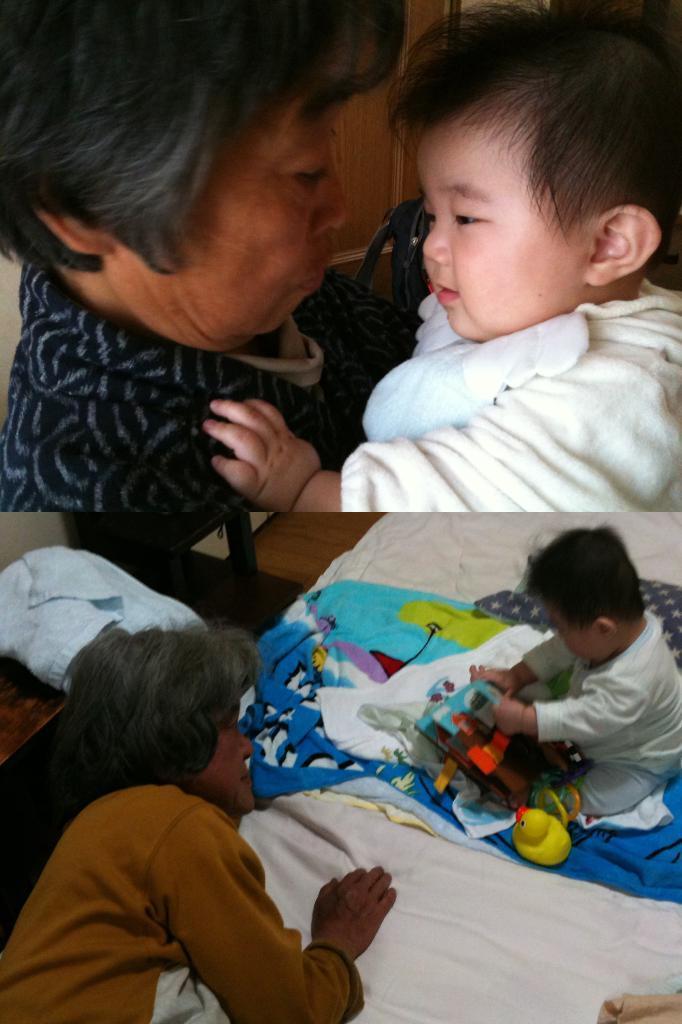How would you summarize this image in a sentence or two? There are two images. In the first image, there is a person holding a baby who is in white color t-shirt. In the second image, there is a person laying on the bed, on which, there is a baby who is in white color t-shirt and is playing with toys. In the background, there is a chair, a cloth on the table and there is wall. 